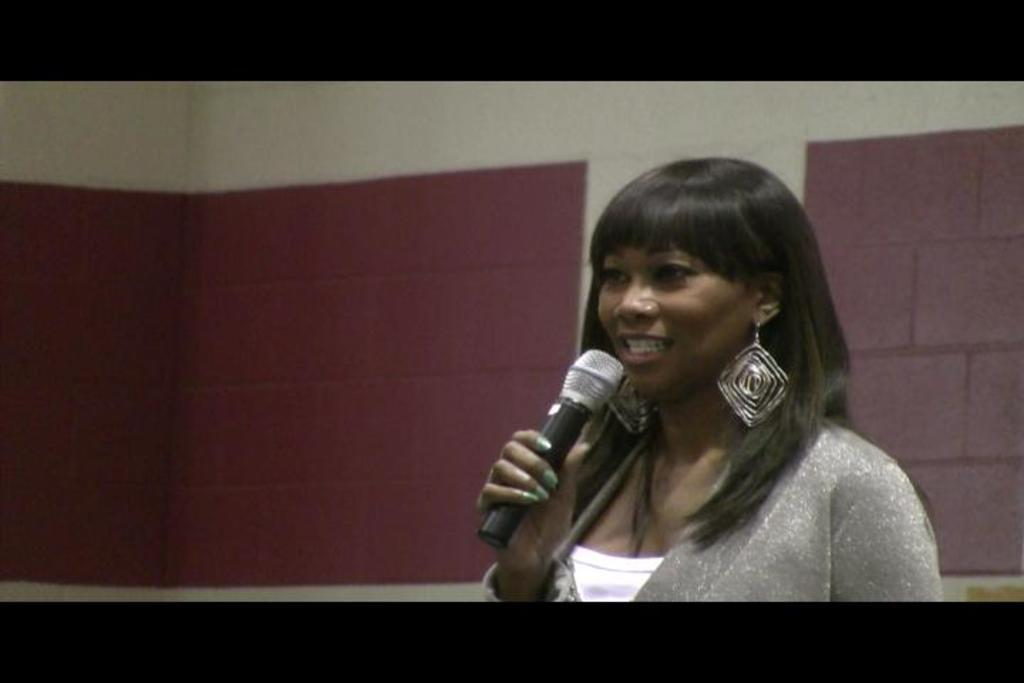Who is the main subject in the image? There is a woman in the image. What is the woman holding in the image? The woman is holding a microphone. What is the woman wearing in the image? The woman is wearing a silver-colored dress. What type of accessories does the woman have in the image? The woman has long hanging accessories. What can be seen in the background of the image? There is a brown-colored wall in the background. What type of pain does the woman in the image experience? There is no indication of pain or discomfort in the image; the woman is holding a microphone and appears to be engaged in an activity. 